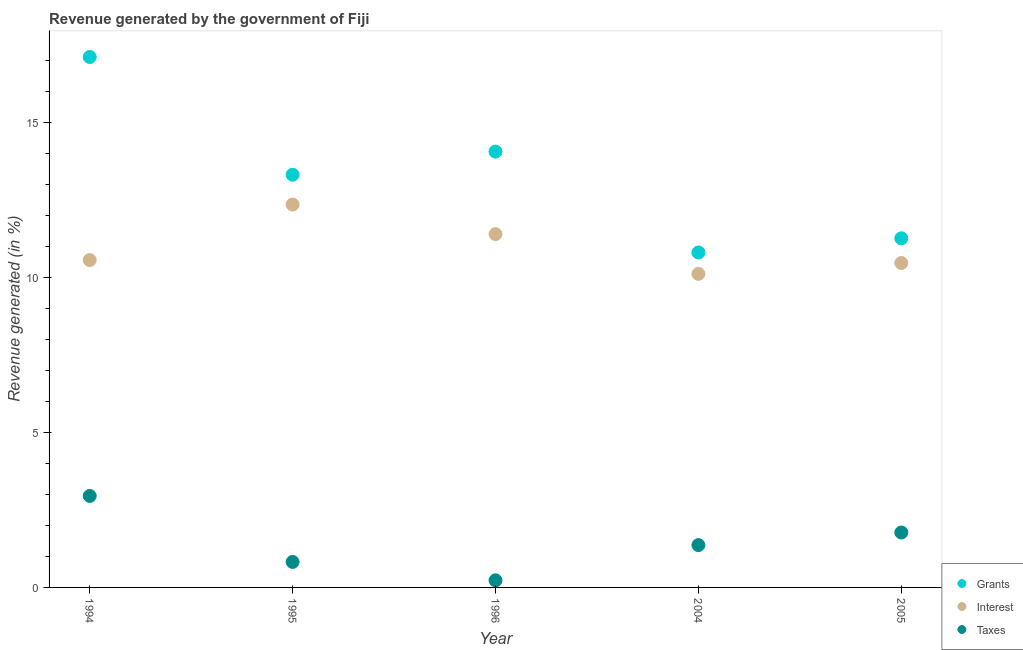What is the percentage of revenue generated by grants in 1996?
Provide a short and direct response. 14.07. Across all years, what is the maximum percentage of revenue generated by grants?
Provide a succinct answer. 17.12. Across all years, what is the minimum percentage of revenue generated by taxes?
Your answer should be compact. 0.23. What is the total percentage of revenue generated by taxes in the graph?
Keep it short and to the point. 7.14. What is the difference between the percentage of revenue generated by taxes in 1995 and that in 2004?
Provide a succinct answer. -0.54. What is the difference between the percentage of revenue generated by taxes in 1996 and the percentage of revenue generated by grants in 2004?
Make the answer very short. -10.58. What is the average percentage of revenue generated by taxes per year?
Keep it short and to the point. 1.43. In the year 2005, what is the difference between the percentage of revenue generated by interest and percentage of revenue generated by taxes?
Provide a succinct answer. 8.7. What is the ratio of the percentage of revenue generated by taxes in 1994 to that in 2005?
Offer a terse response. 1.67. Is the percentage of revenue generated by taxes in 1994 less than that in 2005?
Provide a short and direct response. No. What is the difference between the highest and the second highest percentage of revenue generated by grants?
Provide a succinct answer. 3.05. What is the difference between the highest and the lowest percentage of revenue generated by taxes?
Your response must be concise. 2.72. In how many years, is the percentage of revenue generated by grants greater than the average percentage of revenue generated by grants taken over all years?
Ensure brevity in your answer.  3. Is the sum of the percentage of revenue generated by grants in 1995 and 2004 greater than the maximum percentage of revenue generated by taxes across all years?
Provide a succinct answer. Yes. Is the percentage of revenue generated by interest strictly less than the percentage of revenue generated by taxes over the years?
Provide a succinct answer. No. How many years are there in the graph?
Provide a succinct answer. 5. What is the difference between two consecutive major ticks on the Y-axis?
Provide a succinct answer. 5. Are the values on the major ticks of Y-axis written in scientific E-notation?
Offer a terse response. No. Does the graph contain any zero values?
Offer a terse response. No. Does the graph contain grids?
Provide a succinct answer. No. Where does the legend appear in the graph?
Offer a very short reply. Bottom right. How many legend labels are there?
Make the answer very short. 3. How are the legend labels stacked?
Your answer should be very brief. Vertical. What is the title of the graph?
Keep it short and to the point. Revenue generated by the government of Fiji. Does "Consumption Tax" appear as one of the legend labels in the graph?
Give a very brief answer. No. What is the label or title of the X-axis?
Your answer should be very brief. Year. What is the label or title of the Y-axis?
Your answer should be very brief. Revenue generated (in %). What is the Revenue generated (in %) of Grants in 1994?
Your response must be concise. 17.12. What is the Revenue generated (in %) of Interest in 1994?
Offer a terse response. 10.57. What is the Revenue generated (in %) of Taxes in 1994?
Provide a short and direct response. 2.95. What is the Revenue generated (in %) of Grants in 1995?
Ensure brevity in your answer.  13.32. What is the Revenue generated (in %) of Interest in 1995?
Provide a succinct answer. 12.36. What is the Revenue generated (in %) in Taxes in 1995?
Provide a short and direct response. 0.82. What is the Revenue generated (in %) in Grants in 1996?
Give a very brief answer. 14.07. What is the Revenue generated (in %) of Interest in 1996?
Keep it short and to the point. 11.4. What is the Revenue generated (in %) of Taxes in 1996?
Your answer should be compact. 0.23. What is the Revenue generated (in %) in Grants in 2004?
Your answer should be very brief. 10.81. What is the Revenue generated (in %) in Interest in 2004?
Your answer should be very brief. 10.12. What is the Revenue generated (in %) in Taxes in 2004?
Ensure brevity in your answer.  1.37. What is the Revenue generated (in %) in Grants in 2005?
Provide a short and direct response. 11.27. What is the Revenue generated (in %) of Interest in 2005?
Keep it short and to the point. 10.47. What is the Revenue generated (in %) of Taxes in 2005?
Make the answer very short. 1.77. Across all years, what is the maximum Revenue generated (in %) of Grants?
Provide a succinct answer. 17.12. Across all years, what is the maximum Revenue generated (in %) in Interest?
Offer a terse response. 12.36. Across all years, what is the maximum Revenue generated (in %) of Taxes?
Your answer should be compact. 2.95. Across all years, what is the minimum Revenue generated (in %) in Grants?
Your answer should be compact. 10.81. Across all years, what is the minimum Revenue generated (in %) in Interest?
Your answer should be very brief. 10.12. Across all years, what is the minimum Revenue generated (in %) in Taxes?
Provide a short and direct response. 0.23. What is the total Revenue generated (in %) in Grants in the graph?
Your answer should be very brief. 66.59. What is the total Revenue generated (in %) in Interest in the graph?
Ensure brevity in your answer.  54.92. What is the total Revenue generated (in %) in Taxes in the graph?
Provide a short and direct response. 7.14. What is the difference between the Revenue generated (in %) of Grants in 1994 and that in 1995?
Your response must be concise. 3.8. What is the difference between the Revenue generated (in %) of Interest in 1994 and that in 1995?
Your answer should be compact. -1.79. What is the difference between the Revenue generated (in %) of Taxes in 1994 and that in 1995?
Ensure brevity in your answer.  2.13. What is the difference between the Revenue generated (in %) of Grants in 1994 and that in 1996?
Your answer should be compact. 3.05. What is the difference between the Revenue generated (in %) of Interest in 1994 and that in 1996?
Provide a succinct answer. -0.84. What is the difference between the Revenue generated (in %) in Taxes in 1994 and that in 1996?
Offer a terse response. 2.72. What is the difference between the Revenue generated (in %) of Grants in 1994 and that in 2004?
Offer a very short reply. 6.31. What is the difference between the Revenue generated (in %) of Interest in 1994 and that in 2004?
Make the answer very short. 0.45. What is the difference between the Revenue generated (in %) of Taxes in 1994 and that in 2004?
Your response must be concise. 1.59. What is the difference between the Revenue generated (in %) in Grants in 1994 and that in 2005?
Your response must be concise. 5.85. What is the difference between the Revenue generated (in %) of Interest in 1994 and that in 2005?
Offer a terse response. 0.1. What is the difference between the Revenue generated (in %) of Taxes in 1994 and that in 2005?
Offer a terse response. 1.18. What is the difference between the Revenue generated (in %) in Grants in 1995 and that in 1996?
Offer a very short reply. -0.75. What is the difference between the Revenue generated (in %) in Interest in 1995 and that in 1996?
Your response must be concise. 0.96. What is the difference between the Revenue generated (in %) in Taxes in 1995 and that in 1996?
Give a very brief answer. 0.59. What is the difference between the Revenue generated (in %) in Grants in 1995 and that in 2004?
Ensure brevity in your answer.  2.51. What is the difference between the Revenue generated (in %) in Interest in 1995 and that in 2004?
Offer a very short reply. 2.24. What is the difference between the Revenue generated (in %) of Taxes in 1995 and that in 2004?
Ensure brevity in your answer.  -0.54. What is the difference between the Revenue generated (in %) in Grants in 1995 and that in 2005?
Keep it short and to the point. 2.05. What is the difference between the Revenue generated (in %) of Interest in 1995 and that in 2005?
Provide a succinct answer. 1.89. What is the difference between the Revenue generated (in %) of Taxes in 1995 and that in 2005?
Your answer should be very brief. -0.95. What is the difference between the Revenue generated (in %) in Grants in 1996 and that in 2004?
Offer a terse response. 3.26. What is the difference between the Revenue generated (in %) in Interest in 1996 and that in 2004?
Your response must be concise. 1.28. What is the difference between the Revenue generated (in %) of Taxes in 1996 and that in 2004?
Your answer should be very brief. -1.14. What is the difference between the Revenue generated (in %) of Grants in 1996 and that in 2005?
Provide a succinct answer. 2.8. What is the difference between the Revenue generated (in %) in Interest in 1996 and that in 2005?
Your answer should be compact. 0.93. What is the difference between the Revenue generated (in %) of Taxes in 1996 and that in 2005?
Keep it short and to the point. -1.54. What is the difference between the Revenue generated (in %) in Grants in 2004 and that in 2005?
Give a very brief answer. -0.46. What is the difference between the Revenue generated (in %) in Interest in 2004 and that in 2005?
Give a very brief answer. -0.35. What is the difference between the Revenue generated (in %) in Taxes in 2004 and that in 2005?
Make the answer very short. -0.41. What is the difference between the Revenue generated (in %) in Grants in 1994 and the Revenue generated (in %) in Interest in 1995?
Offer a terse response. 4.76. What is the difference between the Revenue generated (in %) in Grants in 1994 and the Revenue generated (in %) in Taxes in 1995?
Your answer should be very brief. 16.3. What is the difference between the Revenue generated (in %) of Interest in 1994 and the Revenue generated (in %) of Taxes in 1995?
Your answer should be compact. 9.74. What is the difference between the Revenue generated (in %) of Grants in 1994 and the Revenue generated (in %) of Interest in 1996?
Keep it short and to the point. 5.72. What is the difference between the Revenue generated (in %) in Grants in 1994 and the Revenue generated (in %) in Taxes in 1996?
Give a very brief answer. 16.89. What is the difference between the Revenue generated (in %) of Interest in 1994 and the Revenue generated (in %) of Taxes in 1996?
Offer a very short reply. 10.34. What is the difference between the Revenue generated (in %) in Grants in 1994 and the Revenue generated (in %) in Interest in 2004?
Ensure brevity in your answer.  7. What is the difference between the Revenue generated (in %) in Grants in 1994 and the Revenue generated (in %) in Taxes in 2004?
Your answer should be very brief. 15.76. What is the difference between the Revenue generated (in %) of Interest in 1994 and the Revenue generated (in %) of Taxes in 2004?
Provide a short and direct response. 9.2. What is the difference between the Revenue generated (in %) of Grants in 1994 and the Revenue generated (in %) of Interest in 2005?
Provide a succinct answer. 6.65. What is the difference between the Revenue generated (in %) of Grants in 1994 and the Revenue generated (in %) of Taxes in 2005?
Your answer should be compact. 15.35. What is the difference between the Revenue generated (in %) in Interest in 1994 and the Revenue generated (in %) in Taxes in 2005?
Your answer should be compact. 8.79. What is the difference between the Revenue generated (in %) of Grants in 1995 and the Revenue generated (in %) of Interest in 1996?
Your response must be concise. 1.92. What is the difference between the Revenue generated (in %) in Grants in 1995 and the Revenue generated (in %) in Taxes in 1996?
Your answer should be very brief. 13.09. What is the difference between the Revenue generated (in %) in Interest in 1995 and the Revenue generated (in %) in Taxes in 1996?
Give a very brief answer. 12.13. What is the difference between the Revenue generated (in %) of Grants in 1995 and the Revenue generated (in %) of Interest in 2004?
Make the answer very short. 3.2. What is the difference between the Revenue generated (in %) in Grants in 1995 and the Revenue generated (in %) in Taxes in 2004?
Ensure brevity in your answer.  11.96. What is the difference between the Revenue generated (in %) of Interest in 1995 and the Revenue generated (in %) of Taxes in 2004?
Provide a short and direct response. 10.99. What is the difference between the Revenue generated (in %) of Grants in 1995 and the Revenue generated (in %) of Interest in 2005?
Offer a terse response. 2.85. What is the difference between the Revenue generated (in %) of Grants in 1995 and the Revenue generated (in %) of Taxes in 2005?
Your answer should be compact. 11.55. What is the difference between the Revenue generated (in %) of Interest in 1995 and the Revenue generated (in %) of Taxes in 2005?
Provide a succinct answer. 10.59. What is the difference between the Revenue generated (in %) in Grants in 1996 and the Revenue generated (in %) in Interest in 2004?
Your answer should be compact. 3.95. What is the difference between the Revenue generated (in %) in Grants in 1996 and the Revenue generated (in %) in Taxes in 2004?
Provide a succinct answer. 12.7. What is the difference between the Revenue generated (in %) in Interest in 1996 and the Revenue generated (in %) in Taxes in 2004?
Ensure brevity in your answer.  10.04. What is the difference between the Revenue generated (in %) in Grants in 1996 and the Revenue generated (in %) in Interest in 2005?
Ensure brevity in your answer.  3.6. What is the difference between the Revenue generated (in %) in Grants in 1996 and the Revenue generated (in %) in Taxes in 2005?
Ensure brevity in your answer.  12.29. What is the difference between the Revenue generated (in %) in Interest in 1996 and the Revenue generated (in %) in Taxes in 2005?
Make the answer very short. 9.63. What is the difference between the Revenue generated (in %) of Grants in 2004 and the Revenue generated (in %) of Interest in 2005?
Ensure brevity in your answer.  0.34. What is the difference between the Revenue generated (in %) of Grants in 2004 and the Revenue generated (in %) of Taxes in 2005?
Your response must be concise. 9.04. What is the difference between the Revenue generated (in %) in Interest in 2004 and the Revenue generated (in %) in Taxes in 2005?
Provide a short and direct response. 8.35. What is the average Revenue generated (in %) of Grants per year?
Provide a short and direct response. 13.32. What is the average Revenue generated (in %) in Interest per year?
Provide a short and direct response. 10.98. What is the average Revenue generated (in %) of Taxes per year?
Provide a succinct answer. 1.43. In the year 1994, what is the difference between the Revenue generated (in %) of Grants and Revenue generated (in %) of Interest?
Offer a terse response. 6.55. In the year 1994, what is the difference between the Revenue generated (in %) in Grants and Revenue generated (in %) in Taxes?
Your response must be concise. 14.17. In the year 1994, what is the difference between the Revenue generated (in %) of Interest and Revenue generated (in %) of Taxes?
Your answer should be very brief. 7.61. In the year 1995, what is the difference between the Revenue generated (in %) of Grants and Revenue generated (in %) of Interest?
Make the answer very short. 0.96. In the year 1995, what is the difference between the Revenue generated (in %) in Grants and Revenue generated (in %) in Taxes?
Your answer should be very brief. 12.5. In the year 1995, what is the difference between the Revenue generated (in %) in Interest and Revenue generated (in %) in Taxes?
Make the answer very short. 11.54. In the year 1996, what is the difference between the Revenue generated (in %) in Grants and Revenue generated (in %) in Interest?
Provide a succinct answer. 2.66. In the year 1996, what is the difference between the Revenue generated (in %) of Grants and Revenue generated (in %) of Taxes?
Give a very brief answer. 13.84. In the year 1996, what is the difference between the Revenue generated (in %) of Interest and Revenue generated (in %) of Taxes?
Make the answer very short. 11.17. In the year 2004, what is the difference between the Revenue generated (in %) of Grants and Revenue generated (in %) of Interest?
Offer a very short reply. 0.69. In the year 2004, what is the difference between the Revenue generated (in %) in Grants and Revenue generated (in %) in Taxes?
Provide a short and direct response. 9.45. In the year 2004, what is the difference between the Revenue generated (in %) in Interest and Revenue generated (in %) in Taxes?
Make the answer very short. 8.75. In the year 2005, what is the difference between the Revenue generated (in %) of Grants and Revenue generated (in %) of Interest?
Ensure brevity in your answer.  0.8. In the year 2005, what is the difference between the Revenue generated (in %) of Grants and Revenue generated (in %) of Taxes?
Offer a very short reply. 9.49. In the year 2005, what is the difference between the Revenue generated (in %) in Interest and Revenue generated (in %) in Taxes?
Make the answer very short. 8.7. What is the ratio of the Revenue generated (in %) in Grants in 1994 to that in 1995?
Your response must be concise. 1.29. What is the ratio of the Revenue generated (in %) of Interest in 1994 to that in 1995?
Your answer should be compact. 0.85. What is the ratio of the Revenue generated (in %) of Taxes in 1994 to that in 1995?
Keep it short and to the point. 3.59. What is the ratio of the Revenue generated (in %) in Grants in 1994 to that in 1996?
Offer a terse response. 1.22. What is the ratio of the Revenue generated (in %) of Interest in 1994 to that in 1996?
Keep it short and to the point. 0.93. What is the ratio of the Revenue generated (in %) of Taxes in 1994 to that in 1996?
Give a very brief answer. 12.88. What is the ratio of the Revenue generated (in %) of Grants in 1994 to that in 2004?
Offer a terse response. 1.58. What is the ratio of the Revenue generated (in %) in Interest in 1994 to that in 2004?
Make the answer very short. 1.04. What is the ratio of the Revenue generated (in %) in Taxes in 1994 to that in 2004?
Give a very brief answer. 2.16. What is the ratio of the Revenue generated (in %) in Grants in 1994 to that in 2005?
Provide a succinct answer. 1.52. What is the ratio of the Revenue generated (in %) of Interest in 1994 to that in 2005?
Provide a short and direct response. 1.01. What is the ratio of the Revenue generated (in %) of Taxes in 1994 to that in 2005?
Your answer should be very brief. 1.67. What is the ratio of the Revenue generated (in %) in Grants in 1995 to that in 1996?
Your answer should be very brief. 0.95. What is the ratio of the Revenue generated (in %) of Interest in 1995 to that in 1996?
Offer a very short reply. 1.08. What is the ratio of the Revenue generated (in %) in Taxes in 1995 to that in 1996?
Offer a very short reply. 3.59. What is the ratio of the Revenue generated (in %) of Grants in 1995 to that in 2004?
Make the answer very short. 1.23. What is the ratio of the Revenue generated (in %) of Interest in 1995 to that in 2004?
Ensure brevity in your answer.  1.22. What is the ratio of the Revenue generated (in %) of Taxes in 1995 to that in 2004?
Provide a succinct answer. 0.6. What is the ratio of the Revenue generated (in %) in Grants in 1995 to that in 2005?
Your answer should be compact. 1.18. What is the ratio of the Revenue generated (in %) of Interest in 1995 to that in 2005?
Offer a very short reply. 1.18. What is the ratio of the Revenue generated (in %) of Taxes in 1995 to that in 2005?
Ensure brevity in your answer.  0.46. What is the ratio of the Revenue generated (in %) of Grants in 1996 to that in 2004?
Provide a short and direct response. 1.3. What is the ratio of the Revenue generated (in %) in Interest in 1996 to that in 2004?
Offer a very short reply. 1.13. What is the ratio of the Revenue generated (in %) of Taxes in 1996 to that in 2004?
Your answer should be compact. 0.17. What is the ratio of the Revenue generated (in %) of Grants in 1996 to that in 2005?
Give a very brief answer. 1.25. What is the ratio of the Revenue generated (in %) of Interest in 1996 to that in 2005?
Offer a terse response. 1.09. What is the ratio of the Revenue generated (in %) of Taxes in 1996 to that in 2005?
Offer a very short reply. 0.13. What is the ratio of the Revenue generated (in %) of Grants in 2004 to that in 2005?
Provide a short and direct response. 0.96. What is the ratio of the Revenue generated (in %) of Interest in 2004 to that in 2005?
Keep it short and to the point. 0.97. What is the ratio of the Revenue generated (in %) of Taxes in 2004 to that in 2005?
Offer a terse response. 0.77. What is the difference between the highest and the second highest Revenue generated (in %) of Grants?
Give a very brief answer. 3.05. What is the difference between the highest and the second highest Revenue generated (in %) in Interest?
Your answer should be compact. 0.96. What is the difference between the highest and the second highest Revenue generated (in %) of Taxes?
Make the answer very short. 1.18. What is the difference between the highest and the lowest Revenue generated (in %) of Grants?
Provide a succinct answer. 6.31. What is the difference between the highest and the lowest Revenue generated (in %) of Interest?
Your answer should be compact. 2.24. What is the difference between the highest and the lowest Revenue generated (in %) in Taxes?
Keep it short and to the point. 2.72. 